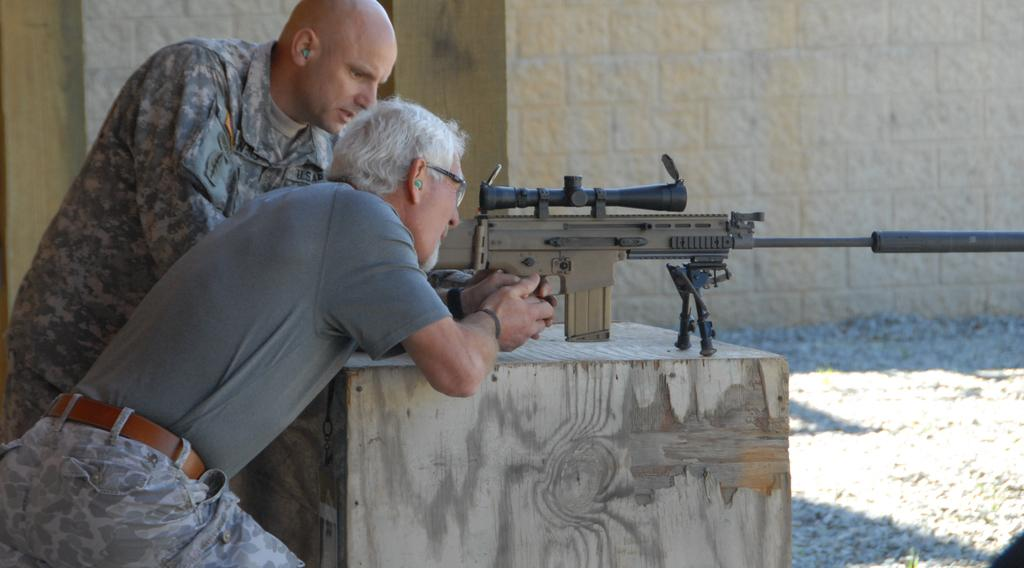How many people are present in the image? There are two people in the image. What structure can be seen in the image? There is a pillar in the image. What object is visible that could be used as a weapon? A gun is visible in the image. What type of construction material is used for the wall in the image? There is a stone wall in the image. What type of leaf is being used as a waste disposal item in the image? There is no leaf or waste disposal item present in the image. What type of earth can be seen in the image? There is no specific type of earth visible in the image. 